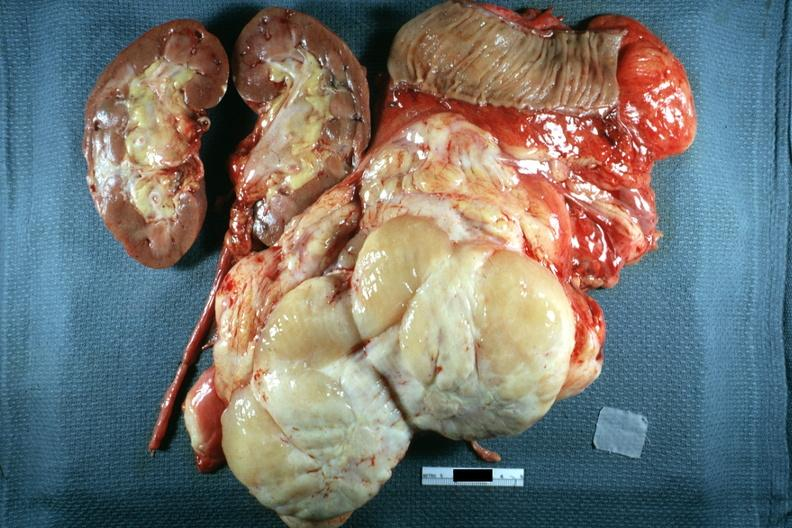what is nodular tumor sectioned?
Answer the question using a single word or phrase. To show cut surface kidney portion of jejunum shown in this surgically resected specimen excellent 